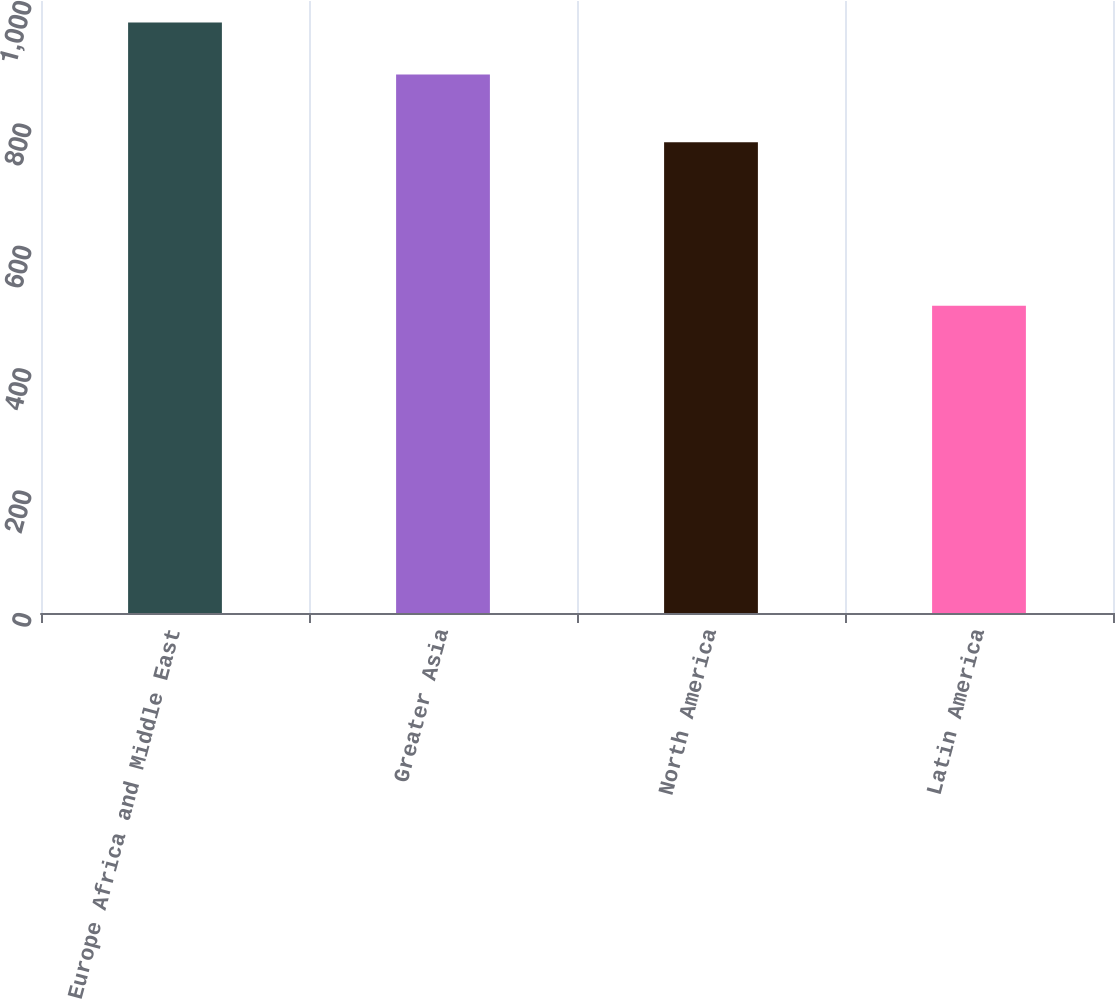<chart> <loc_0><loc_0><loc_500><loc_500><bar_chart><fcel>Europe Africa and Middle East<fcel>Greater Asia<fcel>North America<fcel>Latin America<nl><fcel>965<fcel>880<fcel>769<fcel>502<nl></chart> 